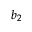<formula> <loc_0><loc_0><loc_500><loc_500>b _ { 2 }</formula> 